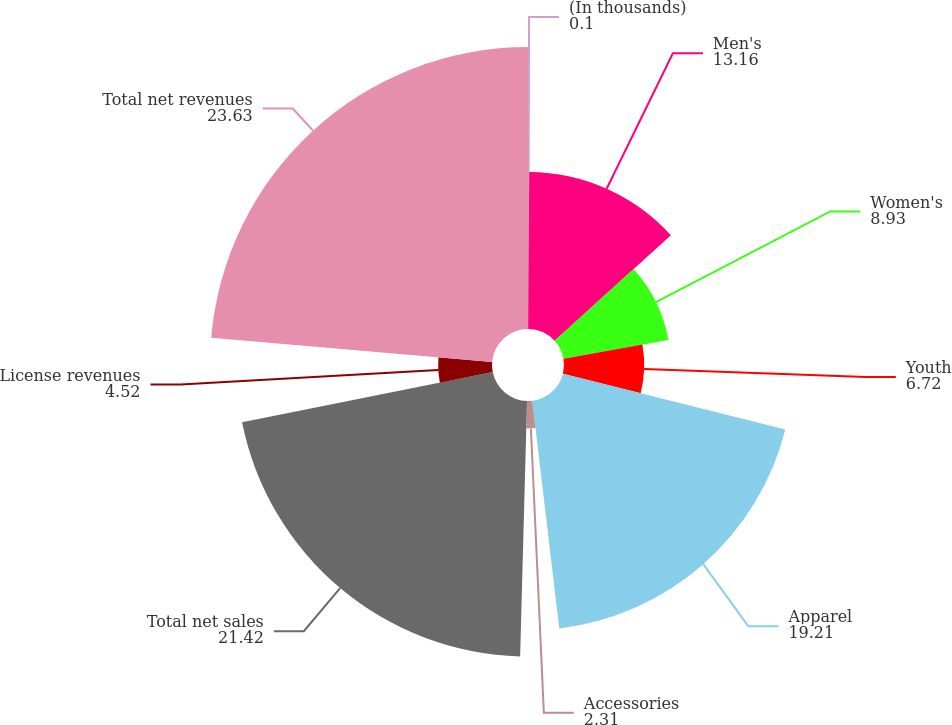Convert chart. <chart><loc_0><loc_0><loc_500><loc_500><pie_chart><fcel>(In thousands)<fcel>Men's<fcel>Women's<fcel>Youth<fcel>Apparel<fcel>Accessories<fcel>Total net sales<fcel>License revenues<fcel>Total net revenues<nl><fcel>0.1%<fcel>13.16%<fcel>8.93%<fcel>6.72%<fcel>19.21%<fcel>2.31%<fcel>21.42%<fcel>4.52%<fcel>23.63%<nl></chart> 